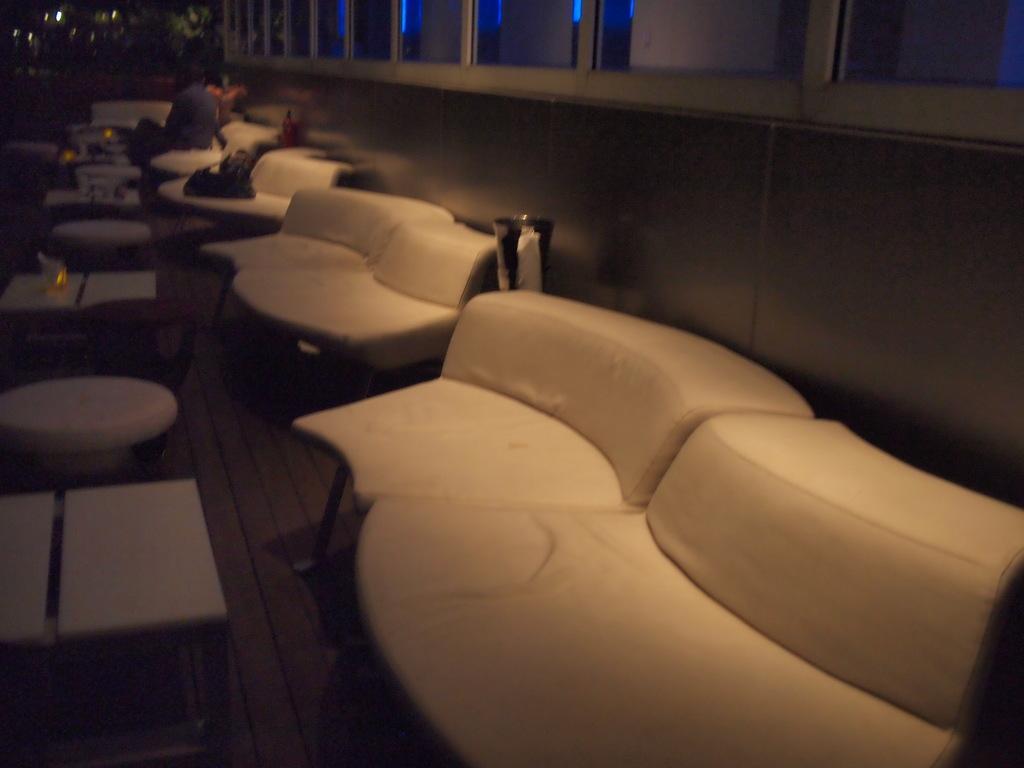Please provide a concise description of this image. In this picture there are many white chairs and tables are visible. Two persons are sitting on a chair. Candles are kept on the table. There are some lights in the background. 